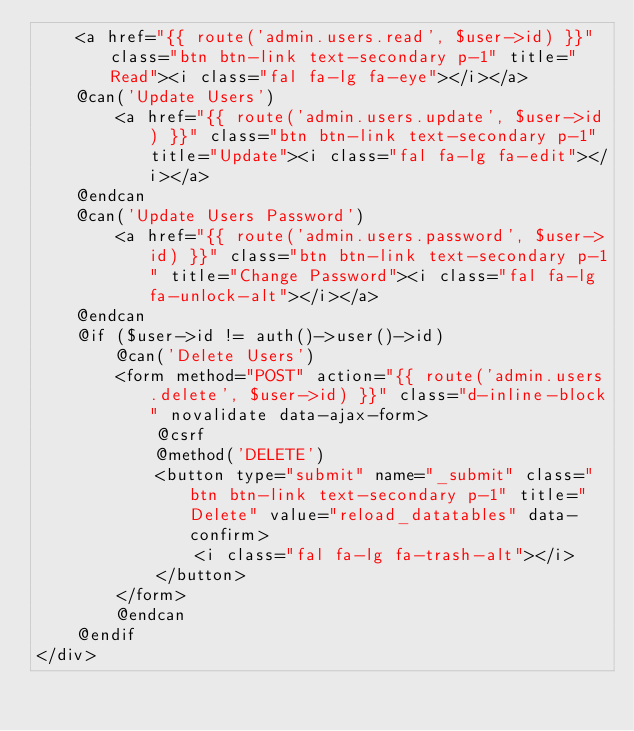Convert code to text. <code><loc_0><loc_0><loc_500><loc_500><_PHP_>    <a href="{{ route('admin.users.read', $user->id) }}" class="btn btn-link text-secondary p-1" title="Read"><i class="fal fa-lg fa-eye"></i></a>
    @can('Update Users')
        <a href="{{ route('admin.users.update', $user->id) }}" class="btn btn-link text-secondary p-1" title="Update"><i class="fal fa-lg fa-edit"></i></a>
    @endcan
    @can('Update Users Password')
        <a href="{{ route('admin.users.password', $user->id) }}" class="btn btn-link text-secondary p-1" title="Change Password"><i class="fal fa-lg fa-unlock-alt"></i></a>
    @endcan
    @if ($user->id != auth()->user()->id)
        @can('Delete Users')
        <form method="POST" action="{{ route('admin.users.delete', $user->id) }}" class="d-inline-block" novalidate data-ajax-form>
            @csrf
            @method('DELETE')
            <button type="submit" name="_submit" class="btn btn-link text-secondary p-1" title="Delete" value="reload_datatables" data-confirm>
                <i class="fal fa-lg fa-trash-alt"></i>
            </button>
        </form>
        @endcan
    @endif
</div></code> 